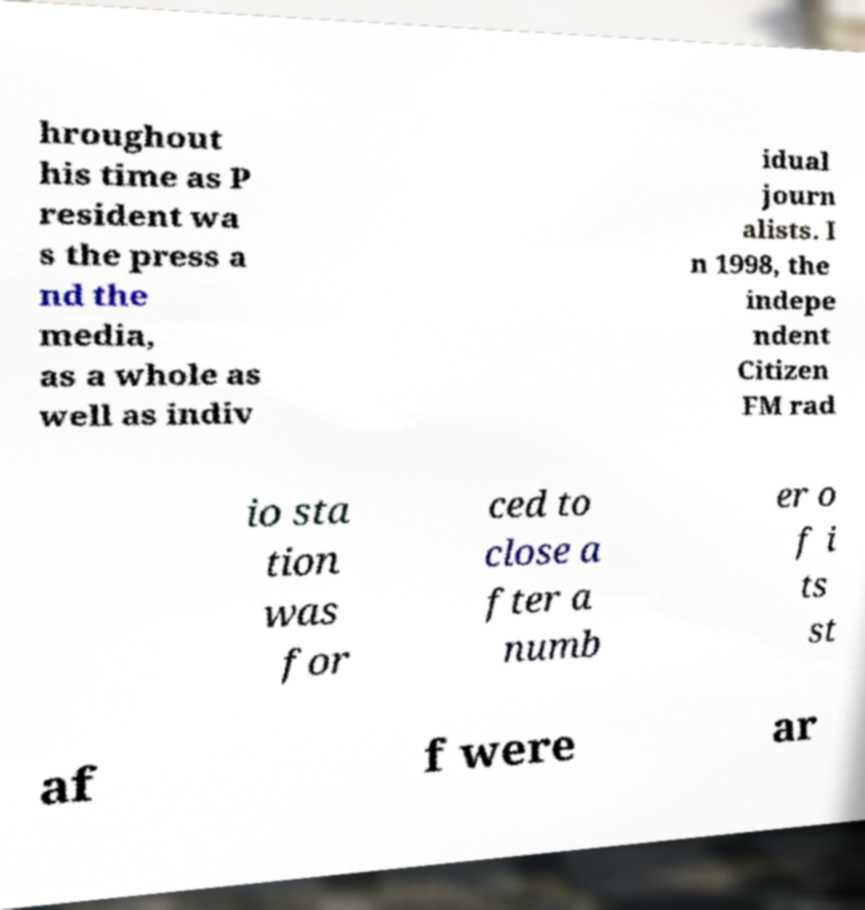Could you assist in decoding the text presented in this image and type it out clearly? hroughout his time as P resident wa s the press a nd the media, as a whole as well as indiv idual journ alists. I n 1998, the indepe ndent Citizen FM rad io sta tion was for ced to close a fter a numb er o f i ts st af f were ar 